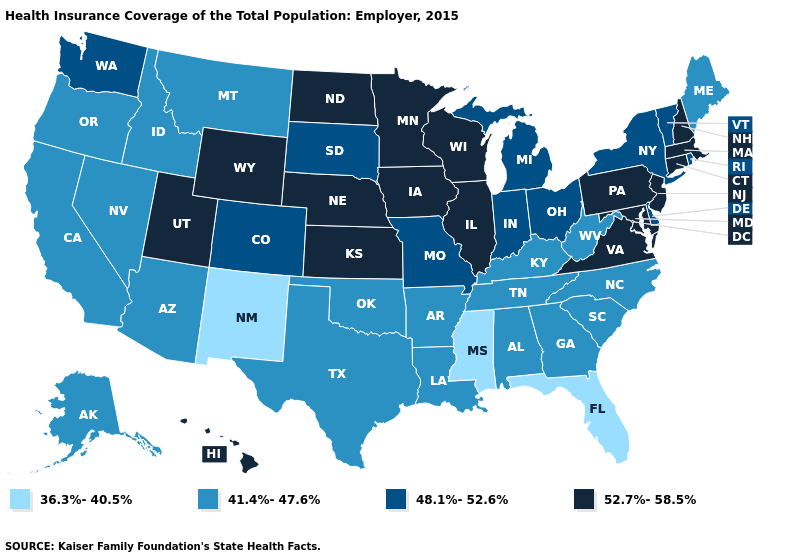What is the value of Idaho?
Give a very brief answer. 41.4%-47.6%. What is the value of West Virginia?
Answer briefly. 41.4%-47.6%. Which states hav the highest value in the MidWest?
Answer briefly. Illinois, Iowa, Kansas, Minnesota, Nebraska, North Dakota, Wisconsin. What is the value of Maryland?
Give a very brief answer. 52.7%-58.5%. Is the legend a continuous bar?
Short answer required. No. Which states have the lowest value in the USA?
Give a very brief answer. Florida, Mississippi, New Mexico. Among the states that border Kentucky , does Virginia have the lowest value?
Quick response, please. No. Which states hav the highest value in the South?
Give a very brief answer. Maryland, Virginia. Does Florida have the lowest value in the USA?
Write a very short answer. Yes. What is the value of Kentucky?
Be succinct. 41.4%-47.6%. What is the value of Georgia?
Quick response, please. 41.4%-47.6%. What is the value of Alaska?
Answer briefly. 41.4%-47.6%. What is the value of Ohio?
Give a very brief answer. 48.1%-52.6%. What is the value of Idaho?
Quick response, please. 41.4%-47.6%. What is the value of Iowa?
Answer briefly. 52.7%-58.5%. 